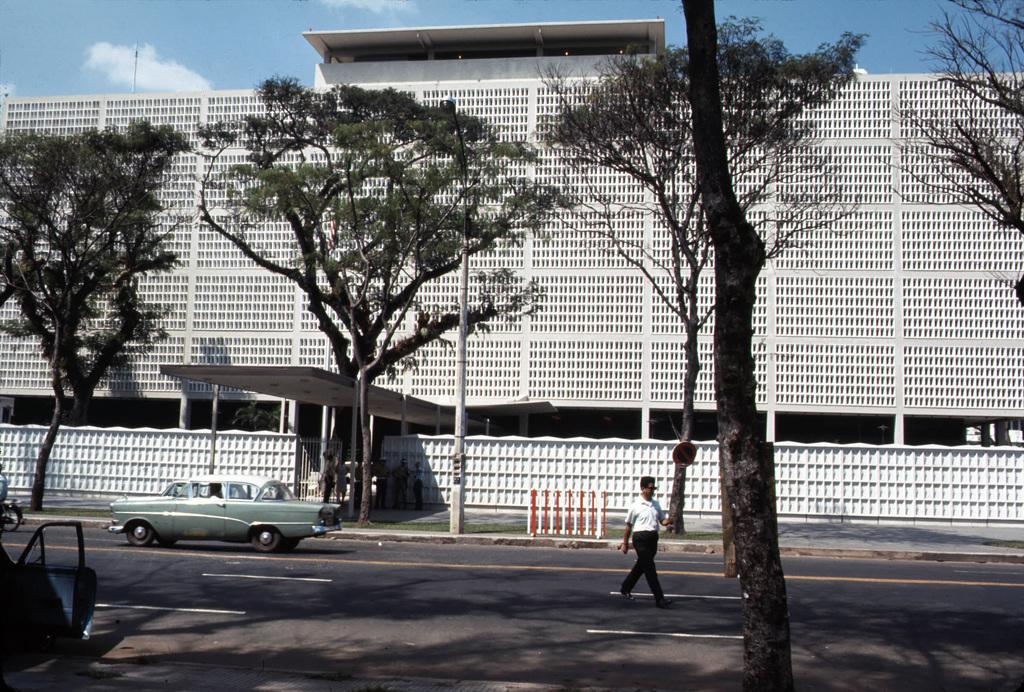What is the main structure in the center of the image? There is a building in the center of the image. What type of natural elements can be seen in the image? There are trees in the image. What is located at the bottom of the image? There is a road at the bottom of the image. Can you describe the person in the image? There is a person walking in the image. What type of vehicles are present in the image? There are cars in the image. What selection of clothes does the father wear in the image? There is no father present in the image, and therefore no clothing selection can be observed. 